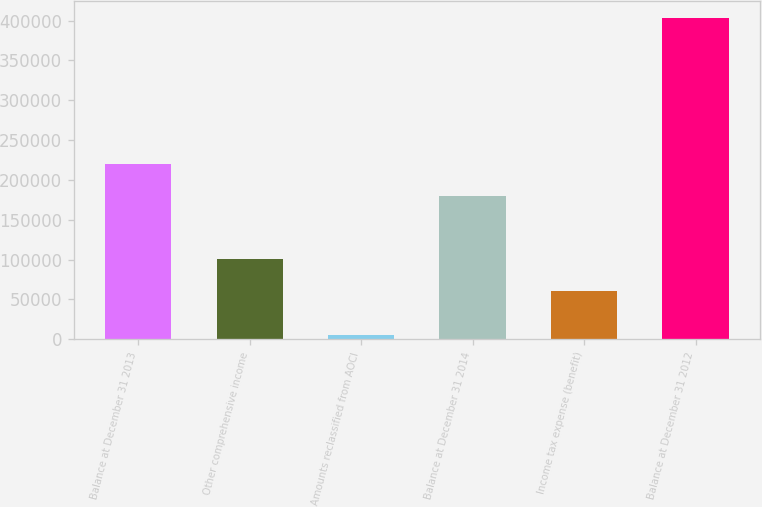<chart> <loc_0><loc_0><loc_500><loc_500><bar_chart><fcel>Balance at December 31 2013<fcel>Other comprehensive income<fcel>Amounts reclassified from AOCI<fcel>Balance at December 31 2014<fcel>Income tax expense (benefit)<fcel>Balance at December 31 2012<nl><fcel>220224<fcel>100652<fcel>5320<fcel>180367<fcel>60795<fcel>403893<nl></chart> 